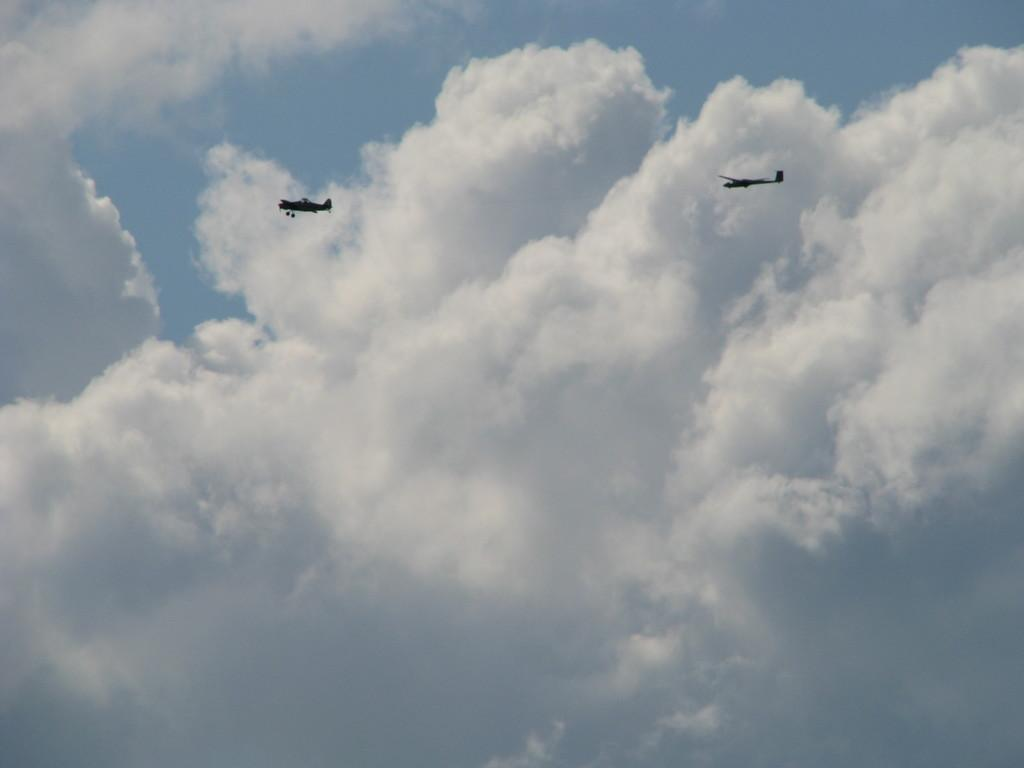What is happening in the sky in the image? There are aeroplanes flying in the air in the image. What can be seen in the background of the image? The sky is visible in the background of the image. What is the condition of the sky in the image? Clouds are present in the sky in the image. How much salt is present in the image? There is no salt present in the image, as it features aeroplanes flying in the sky. Does the image prove the existence of extraterrestrial life? The image does not provide any evidence or information about the existence of extraterrestrial life. 